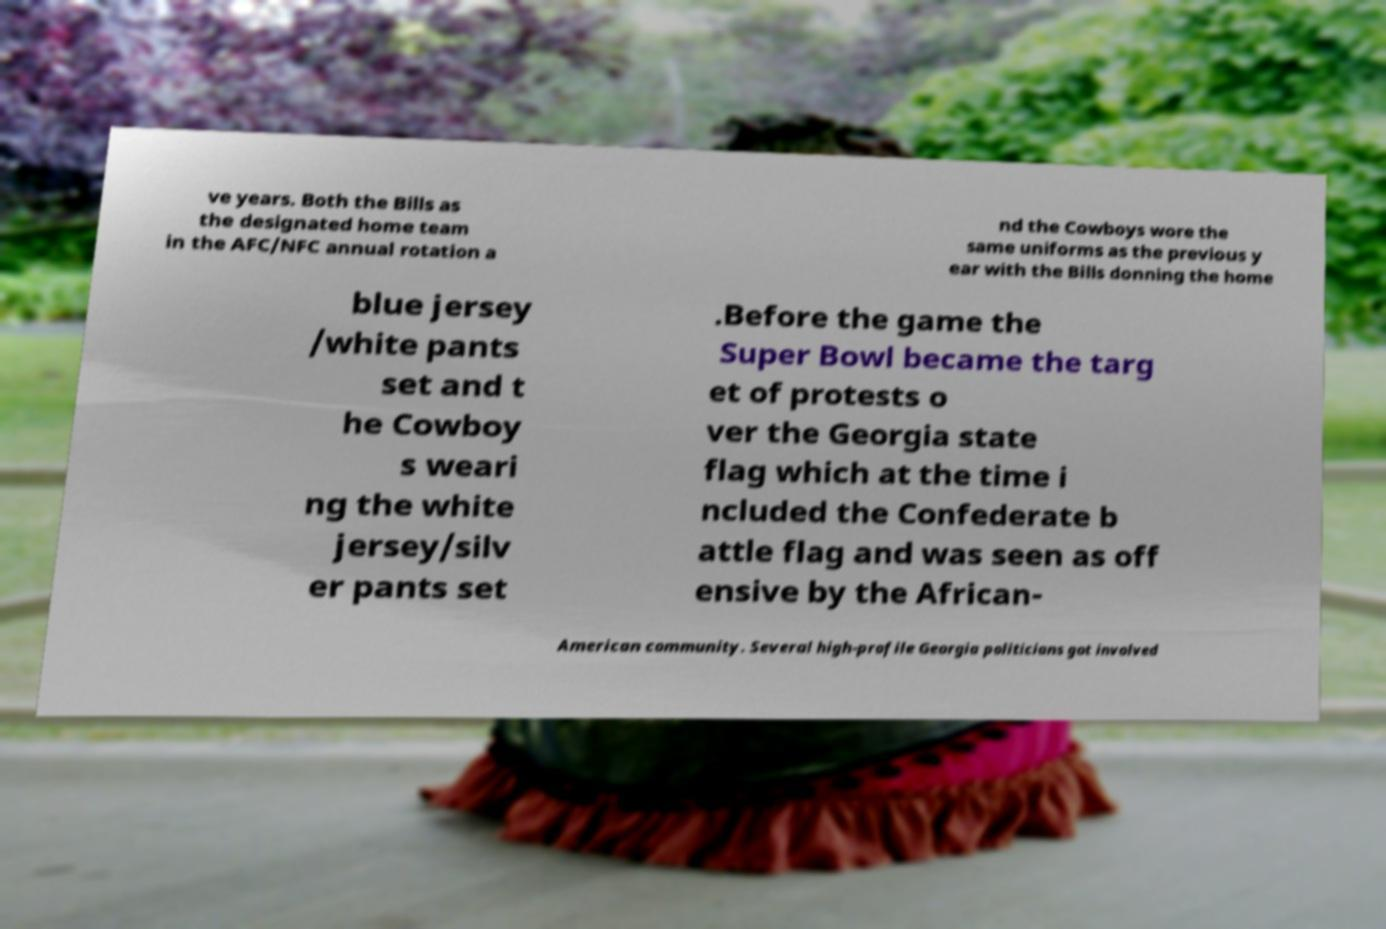Please identify and transcribe the text found in this image. ve years. Both the Bills as the designated home team in the AFC/NFC annual rotation a nd the Cowboys wore the same uniforms as the previous y ear with the Bills donning the home blue jersey /white pants set and t he Cowboy s weari ng the white jersey/silv er pants set .Before the game the Super Bowl became the targ et of protests o ver the Georgia state flag which at the time i ncluded the Confederate b attle flag and was seen as off ensive by the African- American community. Several high-profile Georgia politicians got involved 